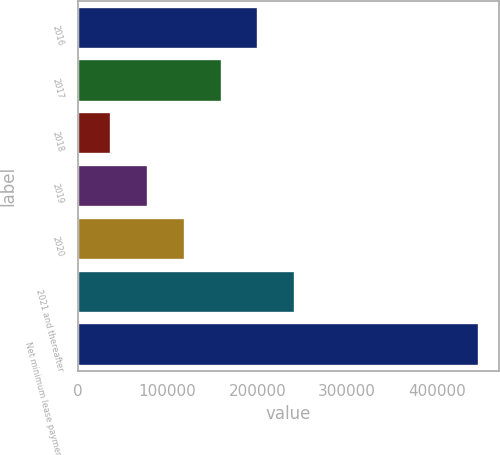<chart> <loc_0><loc_0><loc_500><loc_500><bar_chart><fcel>2016<fcel>2017<fcel>2018<fcel>2019<fcel>2020<fcel>2021 and thereafter<fcel>Net minimum lease payments<nl><fcel>201064<fcel>160148<fcel>37398<fcel>78314.6<fcel>119231<fcel>241981<fcel>446564<nl></chart> 